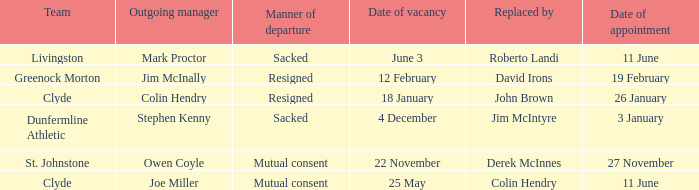Tell me the outgoing manager for livingston Mark Proctor. 